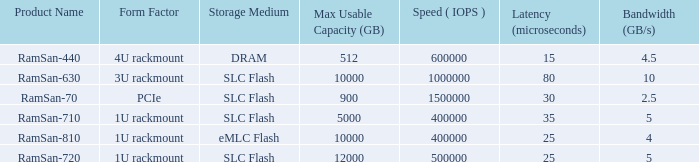List the range distroration for the ramsan-630 3U rackmount. 